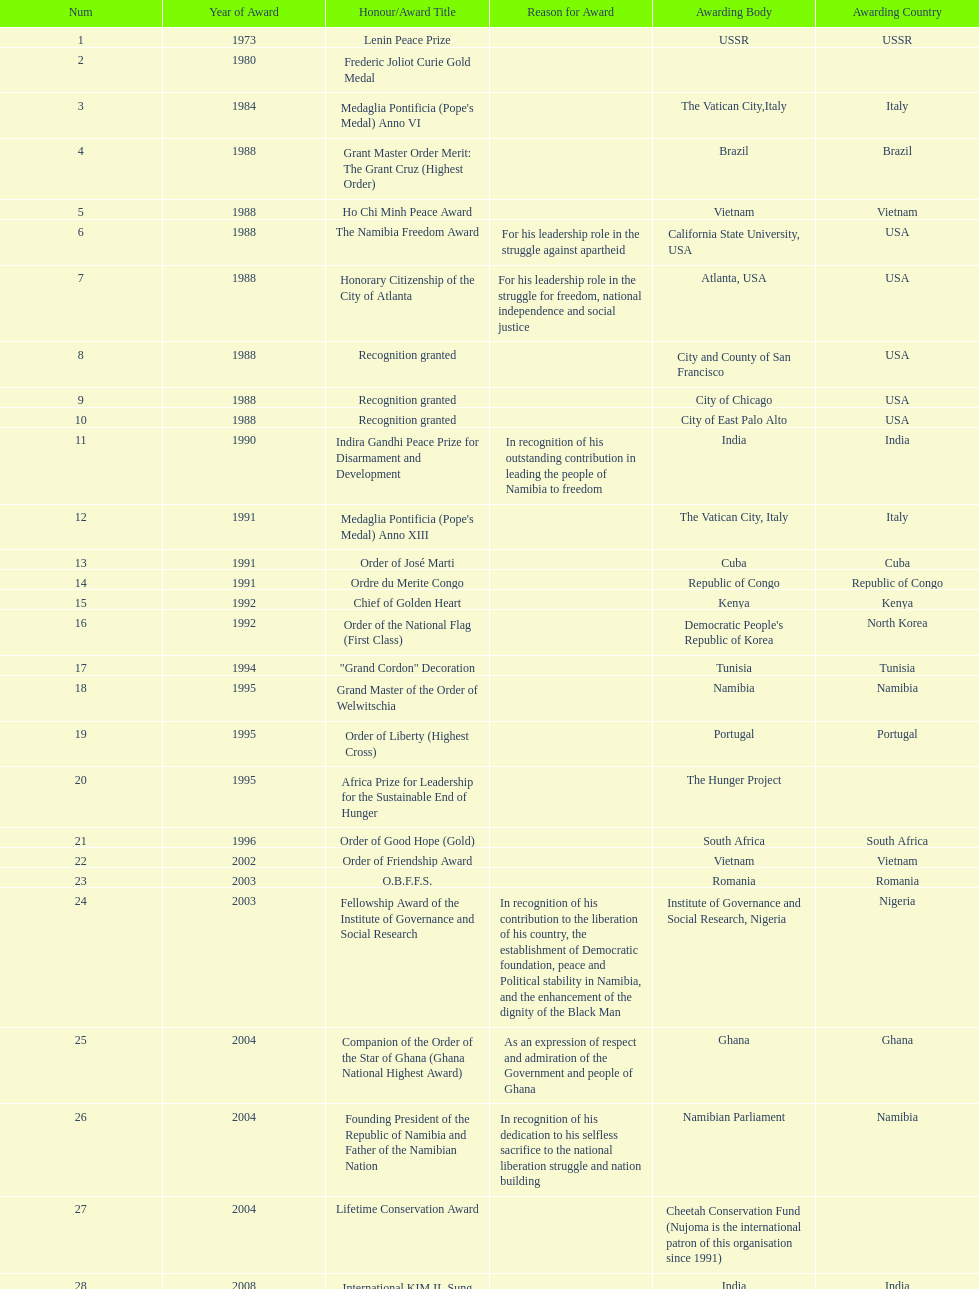What is the last honors/award title listed on this chart? Sir Seretse Khama SADC Meda. Give me the full table as a dictionary. {'header': ['Num', 'Year of Award', 'Honour/Award Title', 'Reason for Award', 'Awarding Body', 'Awarding Country'], 'rows': [['1', '1973', 'Lenin Peace Prize', '', 'USSR', 'USSR'], ['2', '1980', 'Frederic Joliot Curie Gold Medal', '', '', ''], ['3', '1984', "Medaglia Pontificia (Pope's Medal) Anno VI", '', 'The Vatican City,Italy', 'Italy'], ['4', '1988', 'Grant Master Order Merit: The Grant Cruz (Highest Order)', '', 'Brazil', 'Brazil'], ['5', '1988', 'Ho Chi Minh Peace Award', '', 'Vietnam', 'Vietnam'], ['6', '1988', 'The Namibia Freedom Award', 'For his leadership role in the struggle against apartheid', 'California State University, USA', 'USA'], ['7', '1988', 'Honorary Citizenship of the City of Atlanta', 'For his leadership role in the struggle for freedom, national independence and social justice', 'Atlanta, USA', 'USA'], ['8', '1988', 'Recognition granted', '', 'City and County of San Francisco', 'USA'], ['9', '1988', 'Recognition granted', '', 'City of Chicago', 'USA'], ['10', '1988', 'Recognition granted', '', 'City of East Palo Alto', 'USA'], ['11', '1990', 'Indira Gandhi Peace Prize for Disarmament and Development', 'In recognition of his outstanding contribution in leading the people of Namibia to freedom', 'India', 'India'], ['12', '1991', "Medaglia Pontificia (Pope's Medal) Anno XIII", '', 'The Vatican City, Italy', 'Italy'], ['13', '1991', 'Order of José Marti', '', 'Cuba', 'Cuba'], ['14', '1991', 'Ordre du Merite Congo', '', 'Republic of Congo', 'Republic of Congo'], ['15', '1992', 'Chief of Golden Heart', '', 'Kenya', 'Kenya'], ['16', '1992', 'Order of the National Flag (First Class)', '', "Democratic People's Republic of Korea", 'North Korea'], ['17', '1994', '"Grand Cordon" Decoration', '', 'Tunisia', 'Tunisia'], ['18', '1995', 'Grand Master of the Order of Welwitschia', '', 'Namibia', 'Namibia'], ['19', '1995', 'Order of Liberty (Highest Cross)', '', 'Portugal', 'Portugal'], ['20', '1995', 'Africa Prize for Leadership for the Sustainable End of Hunger', '', 'The Hunger Project', ''], ['21', '1996', 'Order of Good Hope (Gold)', '', 'South Africa', 'South Africa'], ['22', '2002', 'Order of Friendship Award', '', 'Vietnam', 'Vietnam'], ['23', '2003', 'O.B.F.F.S.', '', 'Romania', 'Romania'], ['24', '2003', 'Fellowship Award of the Institute of Governance and Social Research', 'In recognition of his contribution to the liberation of his country, the establishment of Democratic foundation, peace and Political stability in Namibia, and the enhancement of the dignity of the Black Man', 'Institute of Governance and Social Research, Nigeria', 'Nigeria'], ['25', '2004', 'Companion of the Order of the Star of Ghana (Ghana National Highest Award)', 'As an expression of respect and admiration of the Government and people of Ghana', 'Ghana', 'Ghana'], ['26', '2004', 'Founding President of the Republic of Namibia and Father of the Namibian Nation', 'In recognition of his dedication to his selfless sacrifice to the national liberation struggle and nation building', 'Namibian Parliament', 'Namibia'], ['27', '2004', 'Lifetime Conservation Award', '', 'Cheetah Conservation Fund (Nujoma is the international patron of this organisation since 1991)', ''], ['28', '2008', 'International KIM IL Sung Prize Certificate', '', 'India', 'India'], ['29', '2010', 'Sir Seretse Khama SADC Meda', '', 'SADC', '']]} 